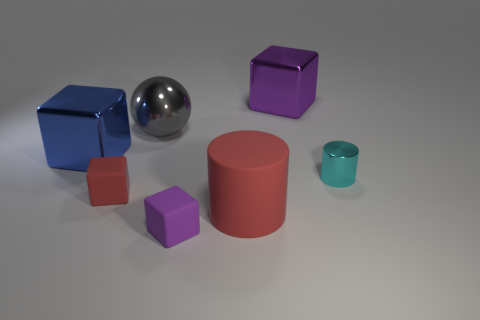Subtract 1 cubes. How many cubes are left? 3 Add 1 rubber things. How many objects exist? 8 Subtract all yellow blocks. Subtract all red cylinders. How many blocks are left? 4 Subtract all blocks. How many objects are left? 3 Add 5 big purple things. How many big purple things exist? 6 Subtract 1 red cylinders. How many objects are left? 6 Subtract all blue matte spheres. Subtract all large red rubber cylinders. How many objects are left? 6 Add 5 large purple shiny blocks. How many large purple shiny blocks are left? 6 